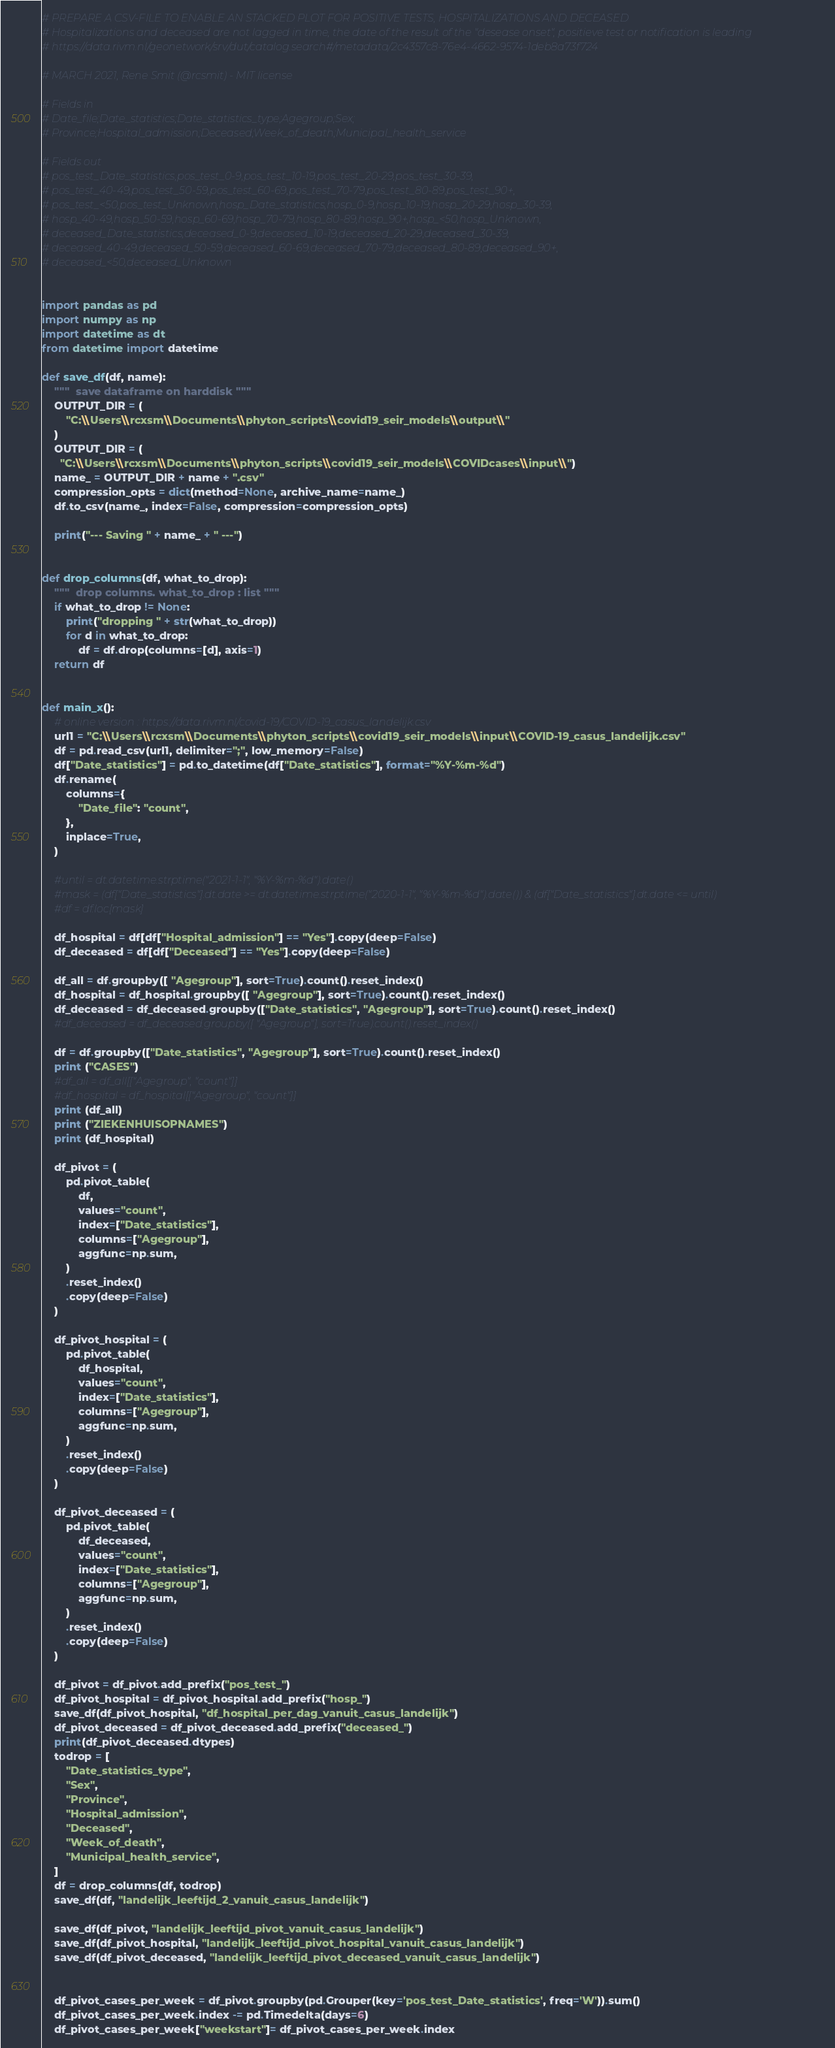<code> <loc_0><loc_0><loc_500><loc_500><_Python_># PREPARE A CSV-FILE TO ENABLE AN STACKED PLOT FOR POSITIVE TESTS, HOSPITALIZATIONS AND DECEASED
# Hospitalizations and deceased are not lagged in time, the date of the result of the "desease onset", positieve test or notification is leading
# https://data.rivm.nl/geonetwork/srv/dut/catalog.search#/metadata/2c4357c8-76e4-4662-9574-1deb8a73f724

# MARCH 2021, Rene Smit (@rcsmit) - MIT license

# Fields in
# Date_file;Date_statistics;Date_statistics_type;Agegroup;Sex;
# Province;Hospital_admission;Deceased;Week_of_death;Municipal_health_service

# Fields out
# pos_test_Date_statistics,pos_test_0-9,pos_test_10-19,pos_test_20-29,pos_test_30-39,
# pos_test_40-49,pos_test_50-59,pos_test_60-69,pos_test_70-79,pos_test_80-89,pos_test_90+,
# pos_test_<50,pos_test_Unknown,hosp_Date_statistics,hosp_0-9,hosp_10-19,hosp_20-29,hosp_30-39,
# hosp_40-49,hosp_50-59,hosp_60-69,hosp_70-79,hosp_80-89,hosp_90+,hosp_<50,hosp_Unknown,
# deceased_Date_statistics,deceased_0-9,deceased_10-19,deceased_20-29,deceased_30-39,
# deceased_40-49,deceased_50-59,deceased_60-69,deceased_70-79,deceased_80-89,deceased_90+,
# deceased_<50,deceased_Unknown


import pandas as pd
import numpy as np
import datetime as dt
from datetime import datetime

def save_df(df, name):
    """  save dataframe on harddisk """
    OUTPUT_DIR = (
        "C:\\Users\\rcxsm\\Documents\\phyton_scripts\\covid19_seir_models\\output\\"
    )
    OUTPUT_DIR = (
      "C:\\Users\\rcxsm\\Documents\\phyton_scripts\\covid19_seir_models\\COVIDcases\\input\\")
    name_ = OUTPUT_DIR + name + ".csv"
    compression_opts = dict(method=None, archive_name=name_)
    df.to_csv(name_, index=False, compression=compression_opts)

    print("--- Saving " + name_ + " ---")


def drop_columns(df, what_to_drop):
    """  drop columns. what_to_drop : list """
    if what_to_drop != None:
        print("dropping " + str(what_to_drop))
        for d in what_to_drop:
            df = df.drop(columns=[d], axis=1)
    return df


def main_x():
    # online version : https://data.rivm.nl/covid-19/COVID-19_casus_landelijk.csv
    url1 = "C:\\Users\\rcxsm\\Documents\\phyton_scripts\\covid19_seir_models\\input\\COVID-19_casus_landelijk.csv"
    df = pd.read_csv(url1, delimiter=";", low_memory=False)
    df["Date_statistics"] = pd.to_datetime(df["Date_statistics"], format="%Y-%m-%d")
    df.rename(
        columns={
            "Date_file": "count",
        },
        inplace=True,
    )

    #until = dt.datetime.strptime("2021-1-1", "%Y-%m-%d").date()
    #mask = (df["Date_statistics"].dt.date >= dt.datetime.strptime("2020-1-1", "%Y-%m-%d").date()) & (df["Date_statistics"].dt.date <= until)
    #df = df.loc[mask]

    df_hospital = df[df["Hospital_admission"] == "Yes"].copy(deep=False)
    df_deceased = df[df["Deceased"] == "Yes"].copy(deep=False)

    df_all = df.groupby([ "Agegroup"], sort=True).count().reset_index()
    df_hospital = df_hospital.groupby([ "Agegroup"], sort=True).count().reset_index()
    df_deceased = df_deceased.groupby(["Date_statistics", "Agegroup"], sort=True).count().reset_index()
    #df_deceased = df_deceased.groupby([ "Agegroup"], sort=True).count().reset_index()

    df = df.groupby(["Date_statistics", "Agegroup"], sort=True).count().reset_index()
    print ("CASES")
    #df_all = df_all[["Agegroup", "count"]]
    #df_hospital = df_hospital[["Agegroup", "count"]]
    print (df_all)
    print ("ZIEKENHUISOPNAMES")
    print (df_hospital)

    df_pivot = (
        pd.pivot_table(
            df,
            values="count",
            index=["Date_statistics"],
            columns=["Agegroup"],
            aggfunc=np.sum,
        )
        .reset_index()
        .copy(deep=False)
    )

    df_pivot_hospital = (
        pd.pivot_table(
            df_hospital,
            values="count",
            index=["Date_statistics"],
            columns=["Agegroup"],
            aggfunc=np.sum,
        )
        .reset_index()
        .copy(deep=False)
    )

    df_pivot_deceased = (
        pd.pivot_table(
            df_deceased,
            values="count",
            index=["Date_statistics"],
            columns=["Agegroup"],
            aggfunc=np.sum,
        )
        .reset_index()
        .copy(deep=False)
    )

    df_pivot = df_pivot.add_prefix("pos_test_")
    df_pivot_hospital = df_pivot_hospital.add_prefix("hosp_")
    save_df(df_pivot_hospital, "df_hospital_per_dag_vanuit_casus_landelijk")
    df_pivot_deceased = df_pivot_deceased.add_prefix("deceased_")
    print(df_pivot_deceased.dtypes)
    todrop = [
        "Date_statistics_type",
        "Sex",
        "Province",
        "Hospital_admission",
        "Deceased",
        "Week_of_death",
        "Municipal_health_service",
    ]
    df = drop_columns(df, todrop)
    save_df(df, "landelijk_leeftijd_2_vanuit_casus_landelijk")

    save_df(df_pivot, "landelijk_leeftijd_pivot_vanuit_casus_landelijk")
    save_df(df_pivot_hospital, "landelijk_leeftijd_pivot_hospital_vanuit_casus_landelijk")
    save_df(df_pivot_deceased, "landelijk_leeftijd_pivot_deceased_vanuit_casus_landelijk")


    df_pivot_cases_per_week = df_pivot.groupby(pd.Grouper(key='pos_test_Date_statistics', freq='W')).sum()
    df_pivot_cases_per_week.index -= pd.Timedelta(days=6)
    df_pivot_cases_per_week["weekstart"]= df_pivot_cases_per_week.index</code> 